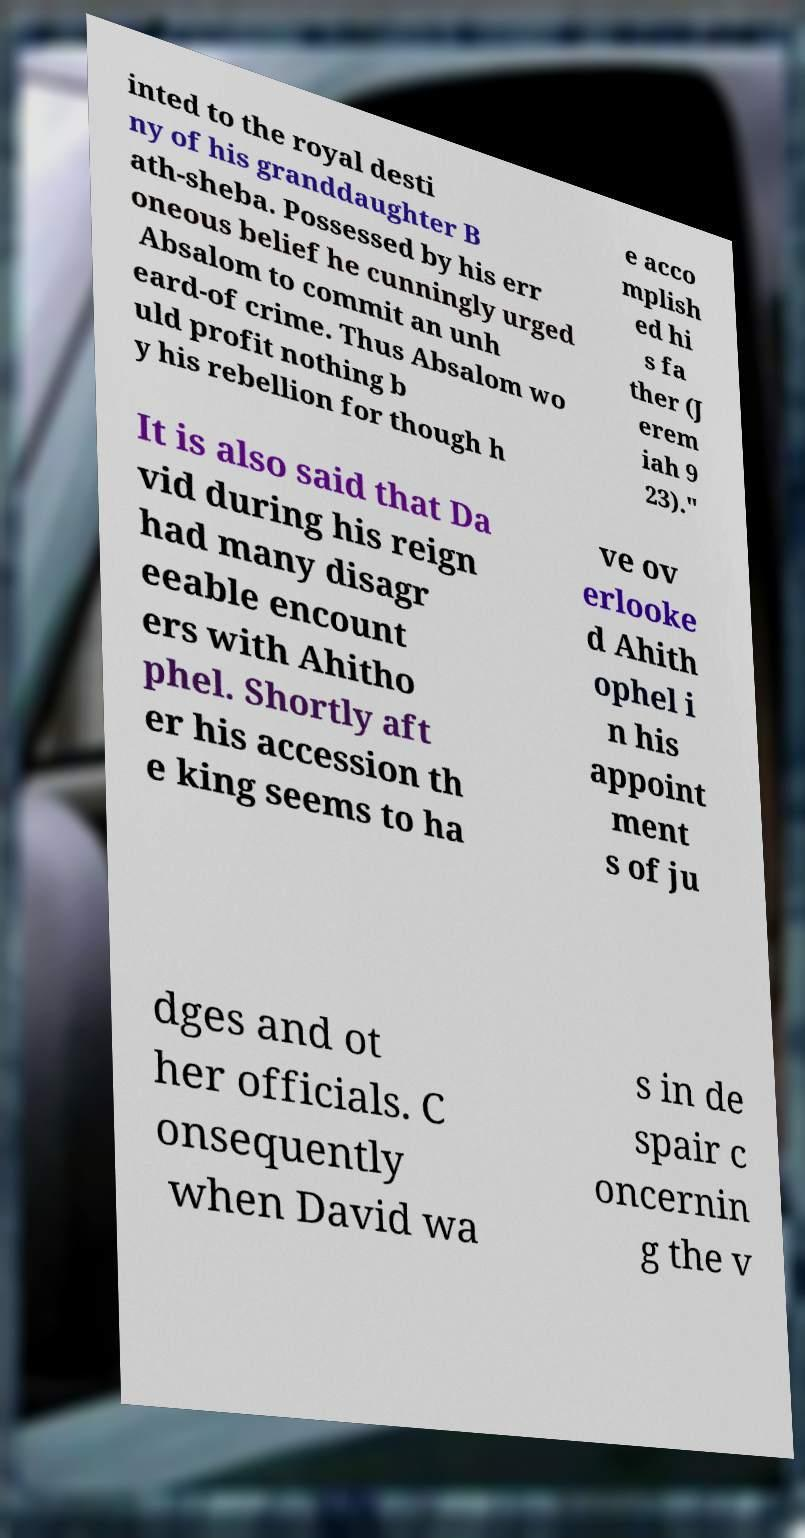There's text embedded in this image that I need extracted. Can you transcribe it verbatim? inted to the royal desti ny of his granddaughter B ath-sheba. Possessed by his err oneous belief he cunningly urged Absalom to commit an unh eard-of crime. Thus Absalom wo uld profit nothing b y his rebellion for though h e acco mplish ed hi s fa ther (J erem iah 9 23)." It is also said that Da vid during his reign had many disagr eeable encount ers with Ahitho phel. Shortly aft er his accession th e king seems to ha ve ov erlooke d Ahith ophel i n his appoint ment s of ju dges and ot her officials. C onsequently when David wa s in de spair c oncernin g the v 